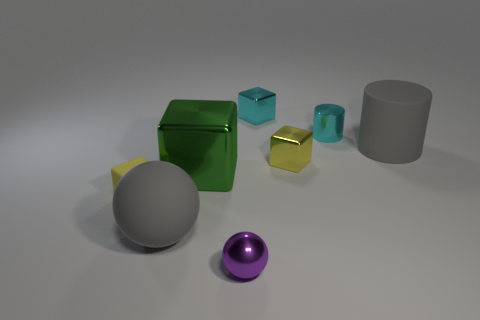Do the rubber sphere and the large rubber cylinder have the same color?
Provide a short and direct response. Yes. There is a rubber object that is to the right of the purple sphere; is its color the same as the large sphere?
Offer a very short reply. Yes. Do the yellow block left of the cyan metallic cube and the large block have the same material?
Provide a short and direct response. No. What color is the tiny sphere that is the same material as the large green cube?
Give a very brief answer. Purple. Are there fewer gray matte cylinders than large green shiny spheres?
Your answer should be very brief. No. What is the material of the sphere on the right side of the big gray rubber object in front of the matte object that is on the right side of the small yellow metal object?
Give a very brief answer. Metal. What is the big cube made of?
Your answer should be very brief. Metal. There is a sphere that is left of the small purple metallic thing; is it the same color as the large matte object behind the yellow matte object?
Offer a very short reply. Yes. Are there more cyan metallic blocks than small cyan things?
Offer a very short reply. No. How many metal blocks are the same color as the matte block?
Offer a very short reply. 1. 